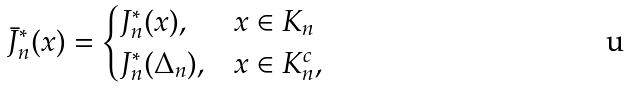<formula> <loc_0><loc_0><loc_500><loc_500>\bar { J } _ { n } ^ { * } ( x ) = \begin{cases} J _ { n } ^ { * } ( x ) , & x \in K _ { n } \\ J _ { n } ^ { * } ( \Delta _ { n } ) , & x \in K _ { n } ^ { c } , \end{cases}</formula> 